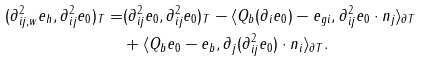Convert formula to latex. <formula><loc_0><loc_0><loc_500><loc_500>( \partial ^ { 2 } _ { i j , w } e _ { h } , \partial ^ { 2 } _ { i j } e _ { 0 } ) _ { T } = & ( \partial ^ { 2 } _ { i j } e _ { 0 } , \partial ^ { 2 } _ { i j } e _ { 0 } ) _ { T } - \langle Q _ { b } ( \partial _ { i } e _ { 0 } ) - e _ { g i } , \partial ^ { 2 } _ { i j } e _ { 0 } \cdot n _ { j } \rangle _ { \partial T } \\ & + \langle Q _ { b } e _ { 0 } - e _ { b } , \partial _ { j } ( \partial ^ { 2 } _ { i j } e _ { 0 } ) \cdot n _ { i } \rangle _ { \partial T } .</formula> 